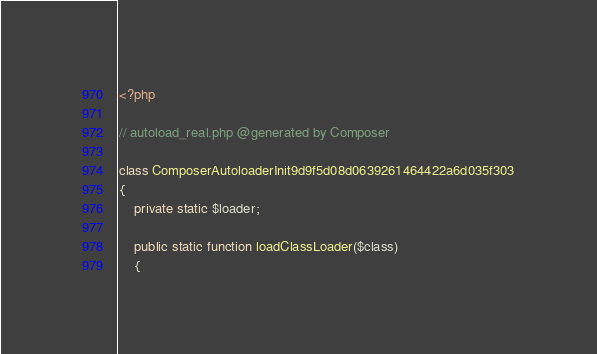Convert code to text. <code><loc_0><loc_0><loc_500><loc_500><_PHP_><?php

// autoload_real.php @generated by Composer

class ComposerAutoloaderInit9d9f5d08d0639261464422a6d035f303
{
    private static $loader;

    public static function loadClassLoader($class)
    {</code> 